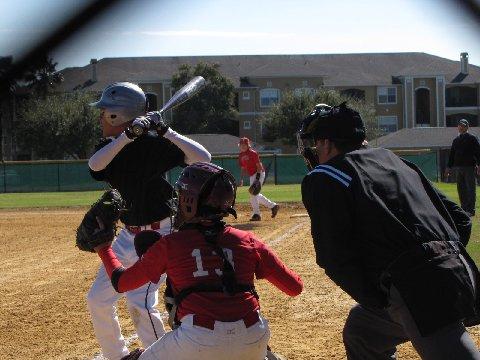Is the baseball player holding a bat?
Be succinct. Yes. Who is winning the game?
Quick response, please. Red team. Does the players helmet and bat match?
Quick response, please. Yes. 